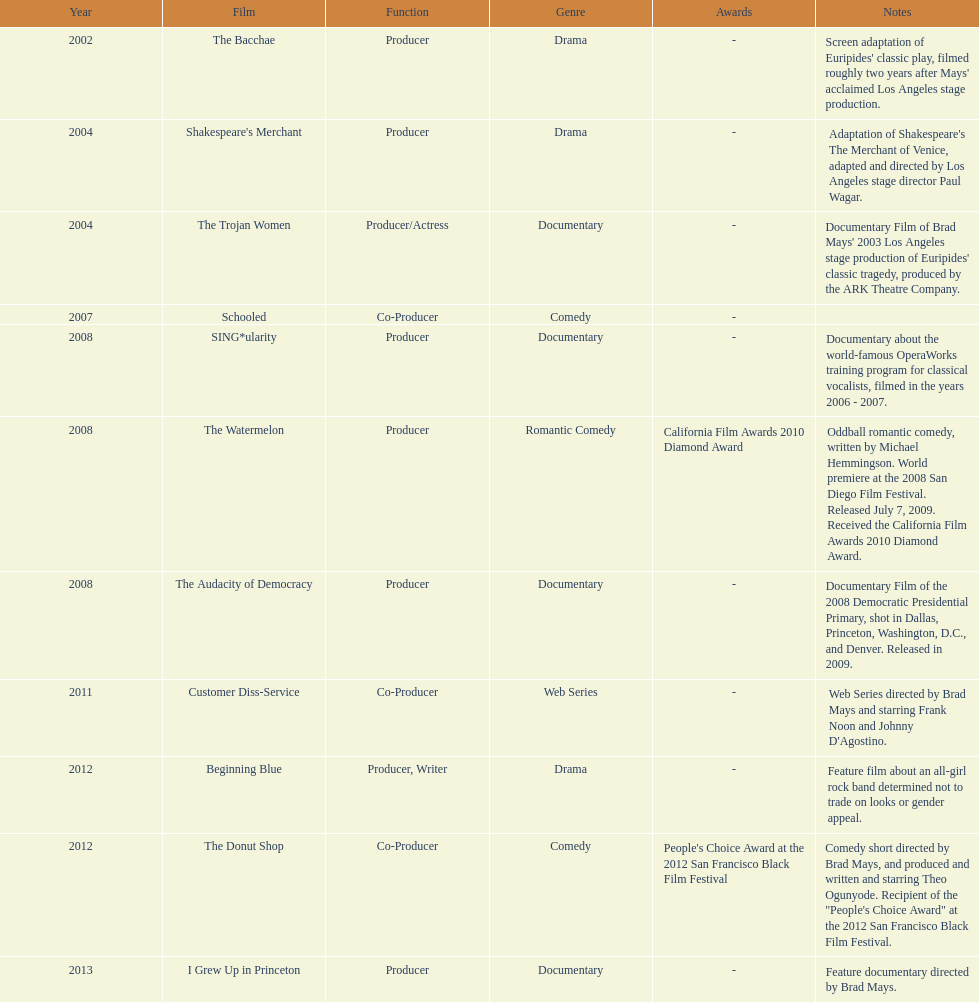What documentary film was produced before the year 2011 but after 2008? The Audacity of Democracy. 